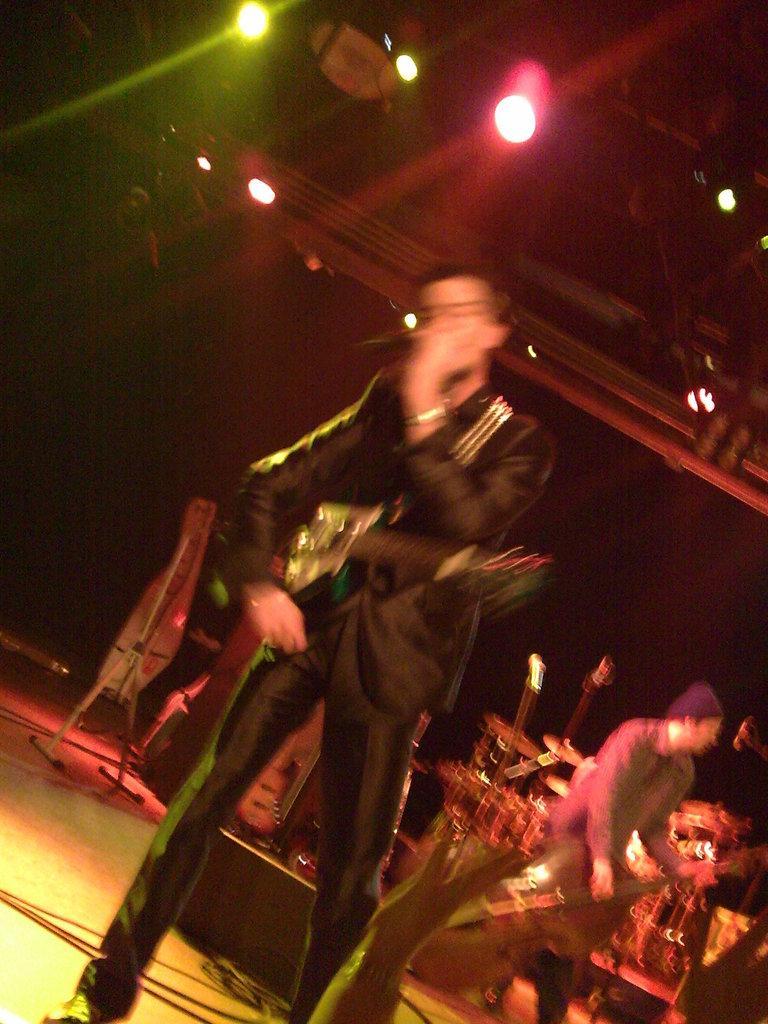In one or two sentences, can you explain what this image depicts? These two persons are standing and holding musical instruments and this person holding microphone. On the background we can see musical instruments,microphones. On the top we can see lights. This is floor. 